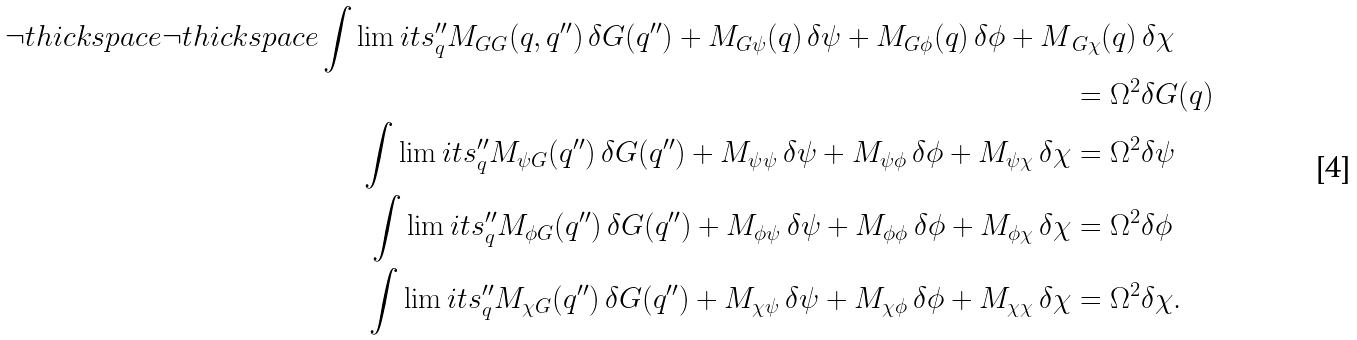Convert formula to latex. <formula><loc_0><loc_0><loc_500><loc_500>\neg t h i c k s p a c e \neg t h i c k s p a c e \int \lim i t s _ { q } ^ { \prime \prime } M _ { G G } ( q , q ^ { \prime \prime } ) \, \delta G ( q ^ { \prime \prime } ) + M _ { G \psi } ( q ) \, \delta \psi + M _ { G \phi } ( q ) \, \delta \phi + M & _ { G \chi } ( q ) \, \delta \chi \\ & = \Omega ^ { 2 } \delta G ( q ) \\ \int \lim i t s _ { q } ^ { \prime \prime } M _ { \psi G } ( q ^ { \prime \prime } ) \, \delta G ( q ^ { \prime \prime } ) + M _ { \psi \psi } \, \delta \psi + M _ { \psi \phi } \, \delta \phi + M _ { \psi \chi } \, \delta \chi & = \Omega ^ { 2 } \delta \psi \\ \int \lim i t s _ { q } ^ { \prime \prime } M _ { \phi G } ( q ^ { \prime \prime } ) \, \delta G ( q ^ { \prime \prime } ) + M _ { \phi \psi } \, \delta \psi + M _ { \phi \phi } \, \delta \phi + M _ { \phi \chi } \, \delta \chi & = \Omega ^ { 2 } \delta \phi \\ \int \lim i t s _ { q } ^ { \prime \prime } M _ { \chi G } ( q ^ { \prime \prime } ) \, \delta G ( q ^ { \prime \prime } ) + M _ { \chi \psi } \, \delta \psi + M _ { \chi \phi } \, \delta \phi + M _ { \chi \chi } \, \delta \chi & = \Omega ^ { 2 } \delta \chi .</formula> 